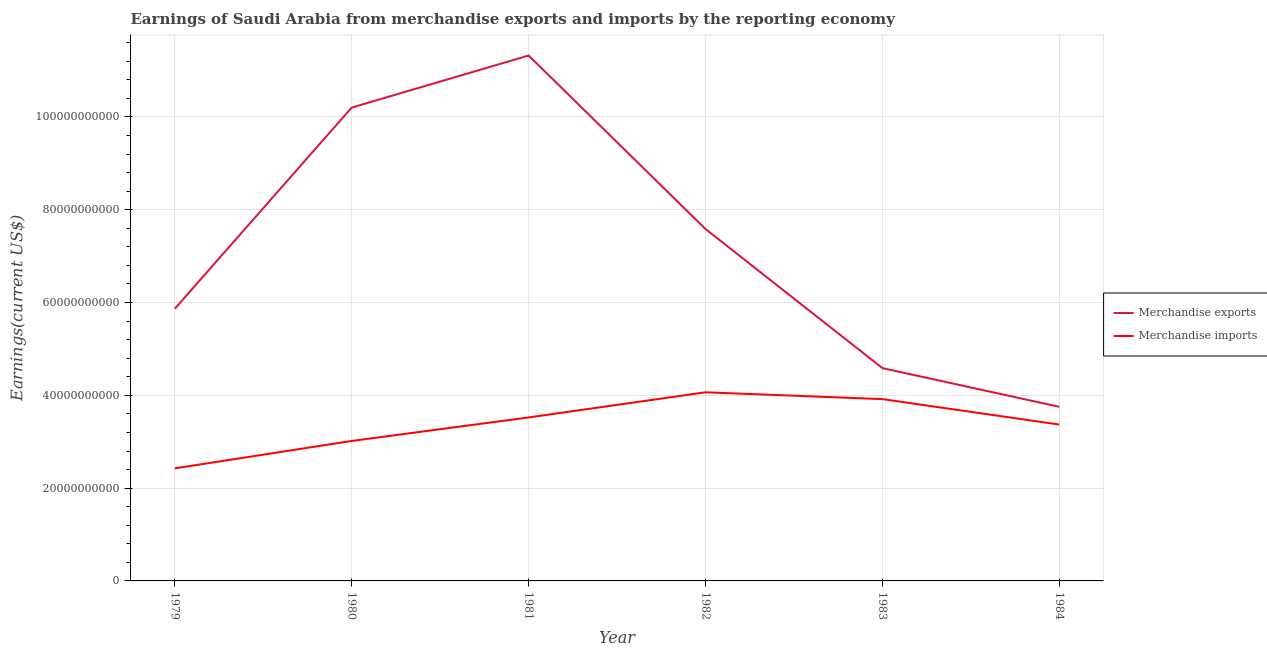How many different coloured lines are there?
Offer a very short reply. 2. What is the earnings from merchandise exports in 1983?
Provide a succinct answer. 4.59e+1. Across all years, what is the maximum earnings from merchandise exports?
Your answer should be compact. 1.13e+11. Across all years, what is the minimum earnings from merchandise exports?
Your answer should be very brief. 3.75e+1. In which year was the earnings from merchandise imports minimum?
Your answer should be compact. 1979. What is the total earnings from merchandise imports in the graph?
Keep it short and to the point. 2.03e+11. What is the difference between the earnings from merchandise imports in 1979 and that in 1984?
Give a very brief answer. -9.44e+09. What is the difference between the earnings from merchandise exports in 1982 and the earnings from merchandise imports in 1983?
Offer a very short reply. 3.67e+1. What is the average earnings from merchandise exports per year?
Your answer should be compact. 7.22e+1. In the year 1979, what is the difference between the earnings from merchandise exports and earnings from merchandise imports?
Provide a succinct answer. 3.44e+1. In how many years, is the earnings from merchandise exports greater than 44000000000 US$?
Provide a short and direct response. 5. What is the ratio of the earnings from merchandise exports in 1980 to that in 1984?
Ensure brevity in your answer.  2.72. Is the difference between the earnings from merchandise imports in 1979 and 1980 greater than the difference between the earnings from merchandise exports in 1979 and 1980?
Keep it short and to the point. Yes. What is the difference between the highest and the second highest earnings from merchandise imports?
Your answer should be compact. 1.47e+09. What is the difference between the highest and the lowest earnings from merchandise exports?
Your response must be concise. 7.57e+1. In how many years, is the earnings from merchandise imports greater than the average earnings from merchandise imports taken over all years?
Offer a very short reply. 3. How many lines are there?
Your answer should be very brief. 2. Where does the legend appear in the graph?
Provide a short and direct response. Center right. How are the legend labels stacked?
Offer a very short reply. Vertical. What is the title of the graph?
Provide a short and direct response. Earnings of Saudi Arabia from merchandise exports and imports by the reporting economy. What is the label or title of the Y-axis?
Offer a terse response. Earnings(current US$). What is the Earnings(current US$) of Merchandise exports in 1979?
Your answer should be compact. 5.87e+1. What is the Earnings(current US$) of Merchandise imports in 1979?
Keep it short and to the point. 2.43e+1. What is the Earnings(current US$) of Merchandise exports in 1980?
Make the answer very short. 1.02e+11. What is the Earnings(current US$) in Merchandise imports in 1980?
Offer a very short reply. 3.02e+1. What is the Earnings(current US$) of Merchandise exports in 1981?
Make the answer very short. 1.13e+11. What is the Earnings(current US$) in Merchandise imports in 1981?
Ensure brevity in your answer.  3.52e+1. What is the Earnings(current US$) in Merchandise exports in 1982?
Give a very brief answer. 7.58e+1. What is the Earnings(current US$) in Merchandise imports in 1982?
Ensure brevity in your answer.  4.07e+1. What is the Earnings(current US$) in Merchandise exports in 1983?
Give a very brief answer. 4.59e+1. What is the Earnings(current US$) of Merchandise imports in 1983?
Keep it short and to the point. 3.92e+1. What is the Earnings(current US$) in Merchandise exports in 1984?
Make the answer very short. 3.75e+1. What is the Earnings(current US$) in Merchandise imports in 1984?
Offer a terse response. 3.37e+1. Across all years, what is the maximum Earnings(current US$) in Merchandise exports?
Your answer should be very brief. 1.13e+11. Across all years, what is the maximum Earnings(current US$) of Merchandise imports?
Keep it short and to the point. 4.07e+1. Across all years, what is the minimum Earnings(current US$) of Merchandise exports?
Give a very brief answer. 3.75e+1. Across all years, what is the minimum Earnings(current US$) of Merchandise imports?
Keep it short and to the point. 2.43e+1. What is the total Earnings(current US$) of Merchandise exports in the graph?
Your answer should be very brief. 4.33e+11. What is the total Earnings(current US$) of Merchandise imports in the graph?
Your answer should be very brief. 2.03e+11. What is the difference between the Earnings(current US$) of Merchandise exports in 1979 and that in 1980?
Provide a succinct answer. -4.34e+1. What is the difference between the Earnings(current US$) in Merchandise imports in 1979 and that in 1980?
Give a very brief answer. -5.91e+09. What is the difference between the Earnings(current US$) in Merchandise exports in 1979 and that in 1981?
Make the answer very short. -5.46e+1. What is the difference between the Earnings(current US$) in Merchandise imports in 1979 and that in 1981?
Offer a very short reply. -1.10e+1. What is the difference between the Earnings(current US$) of Merchandise exports in 1979 and that in 1982?
Your answer should be very brief. -1.72e+1. What is the difference between the Earnings(current US$) of Merchandise imports in 1979 and that in 1982?
Offer a very short reply. -1.64e+1. What is the difference between the Earnings(current US$) in Merchandise exports in 1979 and that in 1983?
Provide a succinct answer. 1.28e+1. What is the difference between the Earnings(current US$) of Merchandise imports in 1979 and that in 1983?
Ensure brevity in your answer.  -1.49e+1. What is the difference between the Earnings(current US$) in Merchandise exports in 1979 and that in 1984?
Provide a short and direct response. 2.11e+1. What is the difference between the Earnings(current US$) in Merchandise imports in 1979 and that in 1984?
Your answer should be very brief. -9.44e+09. What is the difference between the Earnings(current US$) of Merchandise exports in 1980 and that in 1981?
Keep it short and to the point. -1.12e+1. What is the difference between the Earnings(current US$) of Merchandise imports in 1980 and that in 1981?
Your answer should be very brief. -5.07e+09. What is the difference between the Earnings(current US$) in Merchandise exports in 1980 and that in 1982?
Your response must be concise. 2.62e+1. What is the difference between the Earnings(current US$) of Merchandise imports in 1980 and that in 1982?
Your answer should be compact. -1.05e+1. What is the difference between the Earnings(current US$) in Merchandise exports in 1980 and that in 1983?
Ensure brevity in your answer.  5.61e+1. What is the difference between the Earnings(current US$) of Merchandise imports in 1980 and that in 1983?
Offer a terse response. -9.01e+09. What is the difference between the Earnings(current US$) of Merchandise exports in 1980 and that in 1984?
Give a very brief answer. 6.45e+1. What is the difference between the Earnings(current US$) in Merchandise imports in 1980 and that in 1984?
Offer a terse response. -3.53e+09. What is the difference between the Earnings(current US$) of Merchandise exports in 1981 and that in 1982?
Offer a terse response. 3.74e+1. What is the difference between the Earnings(current US$) in Merchandise imports in 1981 and that in 1982?
Keep it short and to the point. -5.42e+09. What is the difference between the Earnings(current US$) of Merchandise exports in 1981 and that in 1983?
Provide a short and direct response. 6.74e+1. What is the difference between the Earnings(current US$) of Merchandise imports in 1981 and that in 1983?
Provide a short and direct response. -3.94e+09. What is the difference between the Earnings(current US$) of Merchandise exports in 1981 and that in 1984?
Offer a terse response. 7.57e+1. What is the difference between the Earnings(current US$) in Merchandise imports in 1981 and that in 1984?
Keep it short and to the point. 1.54e+09. What is the difference between the Earnings(current US$) of Merchandise exports in 1982 and that in 1983?
Make the answer very short. 3.00e+1. What is the difference between the Earnings(current US$) of Merchandise imports in 1982 and that in 1983?
Keep it short and to the point. 1.47e+09. What is the difference between the Earnings(current US$) in Merchandise exports in 1982 and that in 1984?
Give a very brief answer. 3.83e+1. What is the difference between the Earnings(current US$) of Merchandise imports in 1982 and that in 1984?
Make the answer very short. 6.96e+09. What is the difference between the Earnings(current US$) in Merchandise exports in 1983 and that in 1984?
Offer a terse response. 8.34e+09. What is the difference between the Earnings(current US$) of Merchandise imports in 1983 and that in 1984?
Keep it short and to the point. 5.48e+09. What is the difference between the Earnings(current US$) of Merchandise exports in 1979 and the Earnings(current US$) of Merchandise imports in 1980?
Your answer should be compact. 2.85e+1. What is the difference between the Earnings(current US$) in Merchandise exports in 1979 and the Earnings(current US$) in Merchandise imports in 1981?
Provide a short and direct response. 2.34e+1. What is the difference between the Earnings(current US$) of Merchandise exports in 1979 and the Earnings(current US$) of Merchandise imports in 1982?
Your answer should be very brief. 1.80e+1. What is the difference between the Earnings(current US$) in Merchandise exports in 1979 and the Earnings(current US$) in Merchandise imports in 1983?
Your answer should be compact. 1.95e+1. What is the difference between the Earnings(current US$) of Merchandise exports in 1979 and the Earnings(current US$) of Merchandise imports in 1984?
Your response must be concise. 2.50e+1. What is the difference between the Earnings(current US$) in Merchandise exports in 1980 and the Earnings(current US$) in Merchandise imports in 1981?
Offer a very short reply. 6.68e+1. What is the difference between the Earnings(current US$) of Merchandise exports in 1980 and the Earnings(current US$) of Merchandise imports in 1982?
Make the answer very short. 6.14e+1. What is the difference between the Earnings(current US$) of Merchandise exports in 1980 and the Earnings(current US$) of Merchandise imports in 1983?
Your answer should be compact. 6.28e+1. What is the difference between the Earnings(current US$) of Merchandise exports in 1980 and the Earnings(current US$) of Merchandise imports in 1984?
Provide a short and direct response. 6.83e+1. What is the difference between the Earnings(current US$) of Merchandise exports in 1981 and the Earnings(current US$) of Merchandise imports in 1982?
Your answer should be very brief. 7.26e+1. What is the difference between the Earnings(current US$) in Merchandise exports in 1981 and the Earnings(current US$) in Merchandise imports in 1983?
Offer a terse response. 7.41e+1. What is the difference between the Earnings(current US$) of Merchandise exports in 1981 and the Earnings(current US$) of Merchandise imports in 1984?
Your response must be concise. 7.95e+1. What is the difference between the Earnings(current US$) in Merchandise exports in 1982 and the Earnings(current US$) in Merchandise imports in 1983?
Your response must be concise. 3.67e+1. What is the difference between the Earnings(current US$) in Merchandise exports in 1982 and the Earnings(current US$) in Merchandise imports in 1984?
Ensure brevity in your answer.  4.21e+1. What is the difference between the Earnings(current US$) in Merchandise exports in 1983 and the Earnings(current US$) in Merchandise imports in 1984?
Provide a short and direct response. 1.22e+1. What is the average Earnings(current US$) of Merchandise exports per year?
Keep it short and to the point. 7.22e+1. What is the average Earnings(current US$) of Merchandise imports per year?
Your answer should be compact. 3.39e+1. In the year 1979, what is the difference between the Earnings(current US$) in Merchandise exports and Earnings(current US$) in Merchandise imports?
Your response must be concise. 3.44e+1. In the year 1980, what is the difference between the Earnings(current US$) of Merchandise exports and Earnings(current US$) of Merchandise imports?
Give a very brief answer. 7.18e+1. In the year 1981, what is the difference between the Earnings(current US$) of Merchandise exports and Earnings(current US$) of Merchandise imports?
Provide a succinct answer. 7.80e+1. In the year 1982, what is the difference between the Earnings(current US$) of Merchandise exports and Earnings(current US$) of Merchandise imports?
Ensure brevity in your answer.  3.52e+1. In the year 1983, what is the difference between the Earnings(current US$) in Merchandise exports and Earnings(current US$) in Merchandise imports?
Provide a succinct answer. 6.68e+09. In the year 1984, what is the difference between the Earnings(current US$) in Merchandise exports and Earnings(current US$) in Merchandise imports?
Your answer should be compact. 3.83e+09. What is the ratio of the Earnings(current US$) of Merchandise exports in 1979 to that in 1980?
Provide a short and direct response. 0.57. What is the ratio of the Earnings(current US$) in Merchandise imports in 1979 to that in 1980?
Your response must be concise. 0.8. What is the ratio of the Earnings(current US$) of Merchandise exports in 1979 to that in 1981?
Your answer should be very brief. 0.52. What is the ratio of the Earnings(current US$) of Merchandise imports in 1979 to that in 1981?
Keep it short and to the point. 0.69. What is the ratio of the Earnings(current US$) in Merchandise exports in 1979 to that in 1982?
Your answer should be compact. 0.77. What is the ratio of the Earnings(current US$) in Merchandise imports in 1979 to that in 1982?
Your answer should be very brief. 0.6. What is the ratio of the Earnings(current US$) of Merchandise exports in 1979 to that in 1983?
Provide a short and direct response. 1.28. What is the ratio of the Earnings(current US$) in Merchandise imports in 1979 to that in 1983?
Your response must be concise. 0.62. What is the ratio of the Earnings(current US$) in Merchandise exports in 1979 to that in 1984?
Give a very brief answer. 1.56. What is the ratio of the Earnings(current US$) of Merchandise imports in 1979 to that in 1984?
Your answer should be compact. 0.72. What is the ratio of the Earnings(current US$) of Merchandise exports in 1980 to that in 1981?
Ensure brevity in your answer.  0.9. What is the ratio of the Earnings(current US$) of Merchandise imports in 1980 to that in 1981?
Give a very brief answer. 0.86. What is the ratio of the Earnings(current US$) in Merchandise exports in 1980 to that in 1982?
Ensure brevity in your answer.  1.35. What is the ratio of the Earnings(current US$) in Merchandise imports in 1980 to that in 1982?
Keep it short and to the point. 0.74. What is the ratio of the Earnings(current US$) of Merchandise exports in 1980 to that in 1983?
Ensure brevity in your answer.  2.22. What is the ratio of the Earnings(current US$) in Merchandise imports in 1980 to that in 1983?
Offer a terse response. 0.77. What is the ratio of the Earnings(current US$) in Merchandise exports in 1980 to that in 1984?
Your answer should be compact. 2.72. What is the ratio of the Earnings(current US$) in Merchandise imports in 1980 to that in 1984?
Ensure brevity in your answer.  0.9. What is the ratio of the Earnings(current US$) of Merchandise exports in 1981 to that in 1982?
Provide a succinct answer. 1.49. What is the ratio of the Earnings(current US$) of Merchandise imports in 1981 to that in 1982?
Provide a succinct answer. 0.87. What is the ratio of the Earnings(current US$) in Merchandise exports in 1981 to that in 1983?
Provide a succinct answer. 2.47. What is the ratio of the Earnings(current US$) of Merchandise imports in 1981 to that in 1983?
Your answer should be compact. 0.9. What is the ratio of the Earnings(current US$) of Merchandise exports in 1981 to that in 1984?
Provide a succinct answer. 3.02. What is the ratio of the Earnings(current US$) in Merchandise imports in 1981 to that in 1984?
Offer a terse response. 1.05. What is the ratio of the Earnings(current US$) of Merchandise exports in 1982 to that in 1983?
Ensure brevity in your answer.  1.65. What is the ratio of the Earnings(current US$) in Merchandise imports in 1982 to that in 1983?
Provide a succinct answer. 1.04. What is the ratio of the Earnings(current US$) in Merchandise exports in 1982 to that in 1984?
Offer a terse response. 2.02. What is the ratio of the Earnings(current US$) of Merchandise imports in 1982 to that in 1984?
Your answer should be very brief. 1.21. What is the ratio of the Earnings(current US$) of Merchandise exports in 1983 to that in 1984?
Your answer should be compact. 1.22. What is the ratio of the Earnings(current US$) of Merchandise imports in 1983 to that in 1984?
Your answer should be compact. 1.16. What is the difference between the highest and the second highest Earnings(current US$) of Merchandise exports?
Your answer should be very brief. 1.12e+1. What is the difference between the highest and the second highest Earnings(current US$) in Merchandise imports?
Provide a short and direct response. 1.47e+09. What is the difference between the highest and the lowest Earnings(current US$) in Merchandise exports?
Your answer should be very brief. 7.57e+1. What is the difference between the highest and the lowest Earnings(current US$) of Merchandise imports?
Provide a short and direct response. 1.64e+1. 